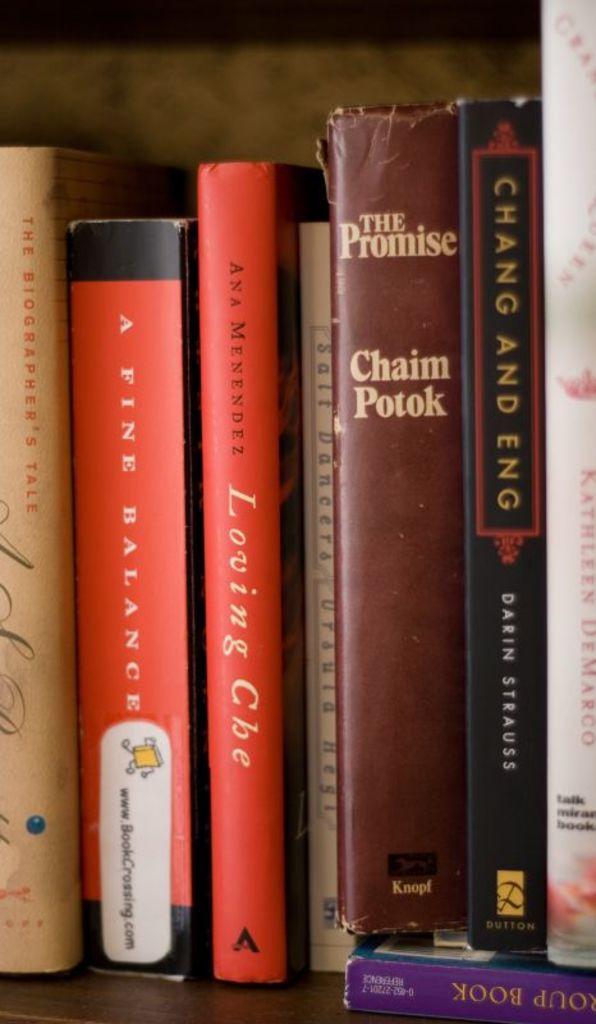Who wrote the promise?
Provide a short and direct response. Chaim potok. 